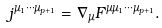Convert formula to latex. <formula><loc_0><loc_0><loc_500><loc_500>j ^ { \mu _ { 1 } \cdots \mu _ { p + 1 } } = \nabla _ { \mu } F ^ { \mu \mu _ { 1 } \cdots \mu _ { p + 1 } } .</formula> 